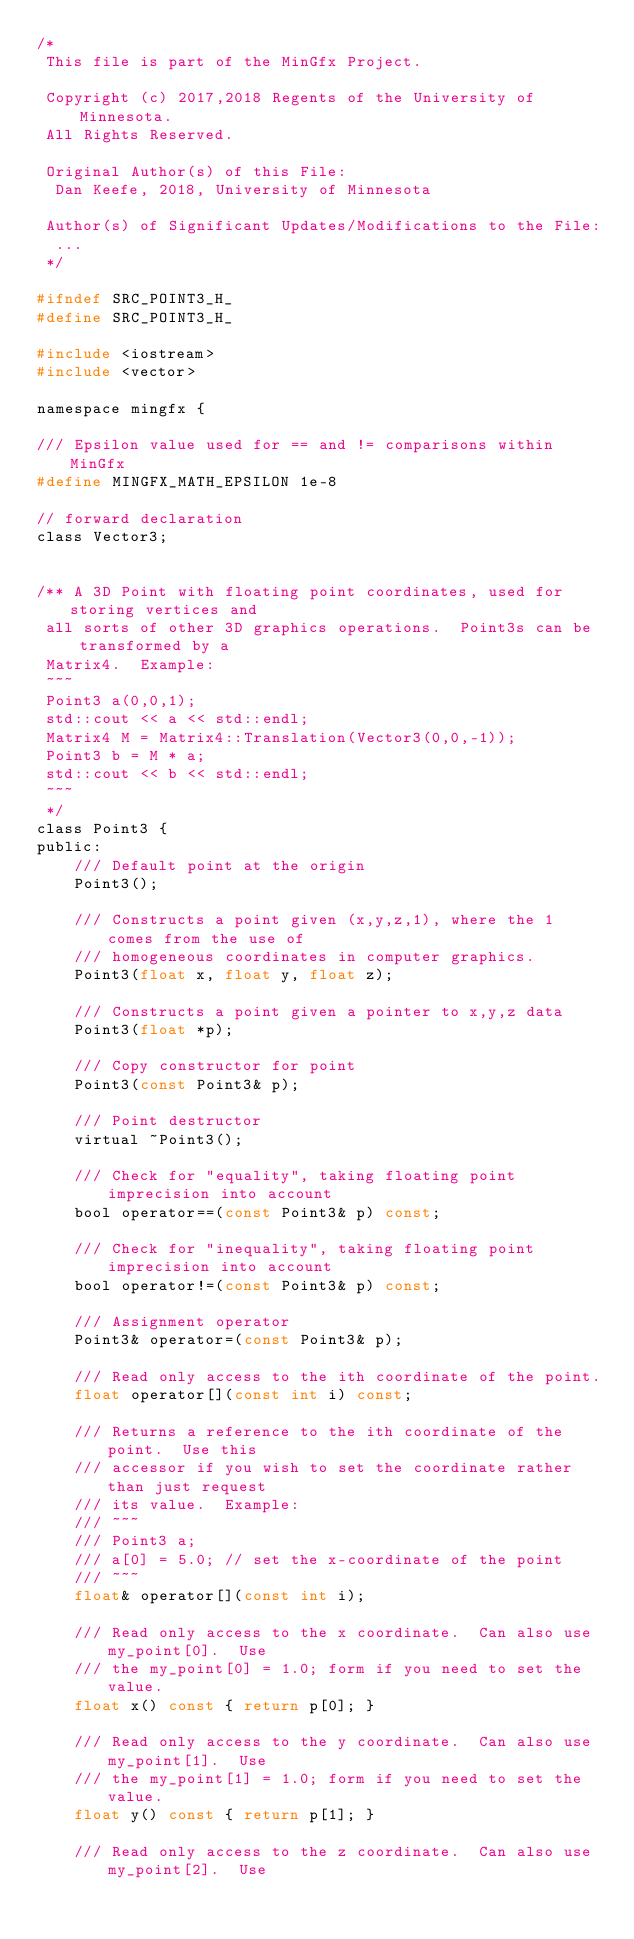<code> <loc_0><loc_0><loc_500><loc_500><_C_>/*
 This file is part of the MinGfx Project.
 
 Copyright (c) 2017,2018 Regents of the University of Minnesota.
 All Rights Reserved.
 
 Original Author(s) of this File:
	Dan Keefe, 2018, University of Minnesota
	
 Author(s) of Significant Updates/Modifications to the File:
	...
 */

#ifndef SRC_POINT3_H_
#define SRC_POINT3_H_

#include <iostream>
#include <vector>

namespace mingfx {

/// Epsilon value used for == and != comparisons within MinGfx
#define MINGFX_MATH_EPSILON 1e-8

// forward declaration
class Vector3;
    
    
/** A 3D Point with floating point coordinates, used for storing vertices and
 all sorts of other 3D graphics operations.  Point3s can be transformed by a
 Matrix4.  Example:
 ~~~
 Point3 a(0,0,1);
 std::cout << a << std::endl;
 Matrix4 M = Matrix4::Translation(Vector3(0,0,-1));
 Point3 b = M * a;
 std::cout << b << std::endl;
 ~~~
 */
class Point3 {
public:  
    /// Default point at the origin
    Point3();

    /// Constructs a point given (x,y,z,1), where the 1 comes from the use of
    /// homogeneous coordinates in computer graphics.
    Point3(float x, float y, float z);

    /// Constructs a point given a pointer to x,y,z data
    Point3(float *p);

    /// Copy constructor for point
    Point3(const Point3& p);

    /// Point destructor
    virtual ~Point3();

    /// Check for "equality", taking floating point imprecision into account
    bool operator==(const Point3& p) const;

    /// Check for "inequality", taking floating point imprecision into account
    bool operator!=(const Point3& p) const;

    /// Assignment operator
    Point3& operator=(const Point3& p);

    /// Read only access to the ith coordinate of the point.
    float operator[](const int i) const;
    
    /// Returns a reference to the ith coordinate of the point.  Use this
    /// accessor if you wish to set the coordinate rather than just request
    /// its value.  Example:
    /// ~~~
    /// Point3 a;
    /// a[0] = 5.0; // set the x-coordinate of the point
    /// ~~~
    float& operator[](const int i);
    
    /// Read only access to the x coordinate.  Can also use my_point[0].  Use
    /// the my_point[0] = 1.0; form if you need to set the value.
    float x() const { return p[0]; }
    
    /// Read only access to the y coordinate.  Can also use my_point[1].  Use
    /// the my_point[1] = 1.0; form if you need to set the value.
    float y() const { return p[1]; }
    
    /// Read only access to the z coordinate.  Can also use my_point[2].  Use</code> 